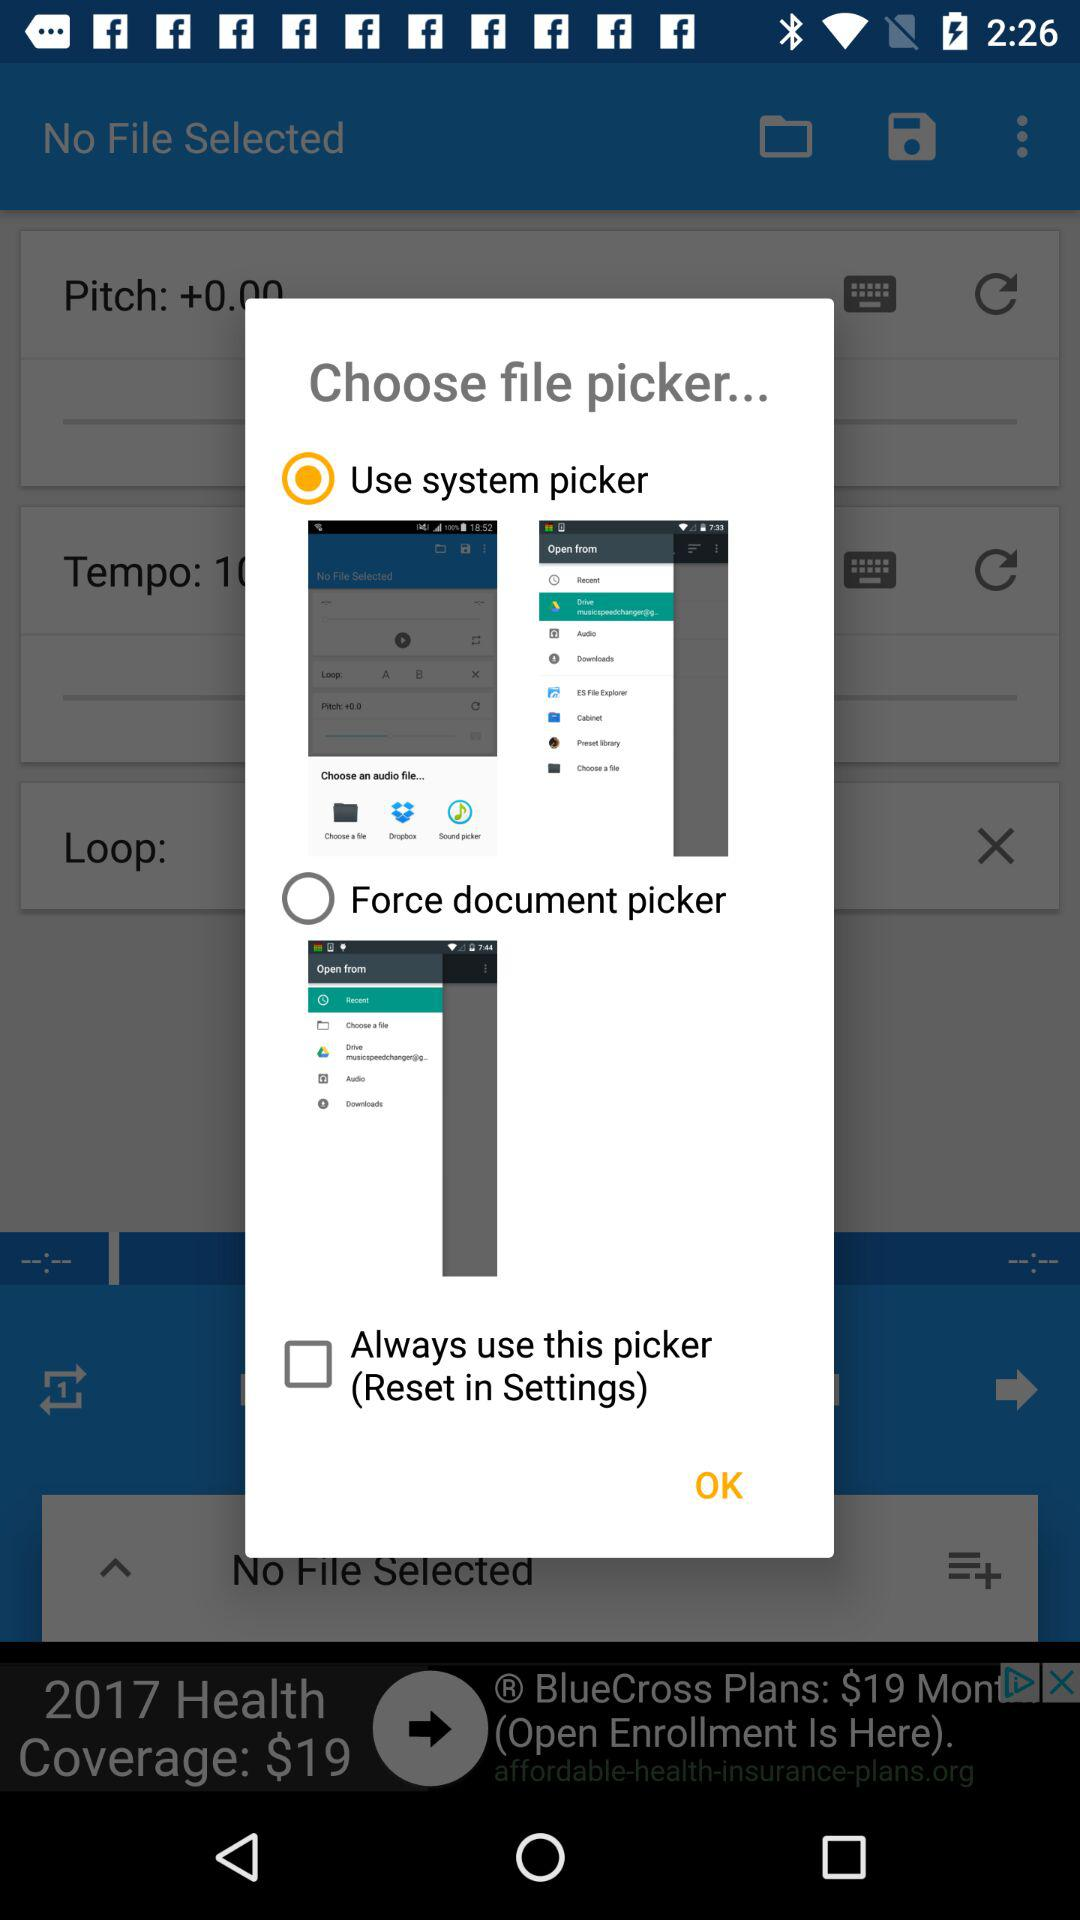What option is selected? The selected option is "Use system picker". 